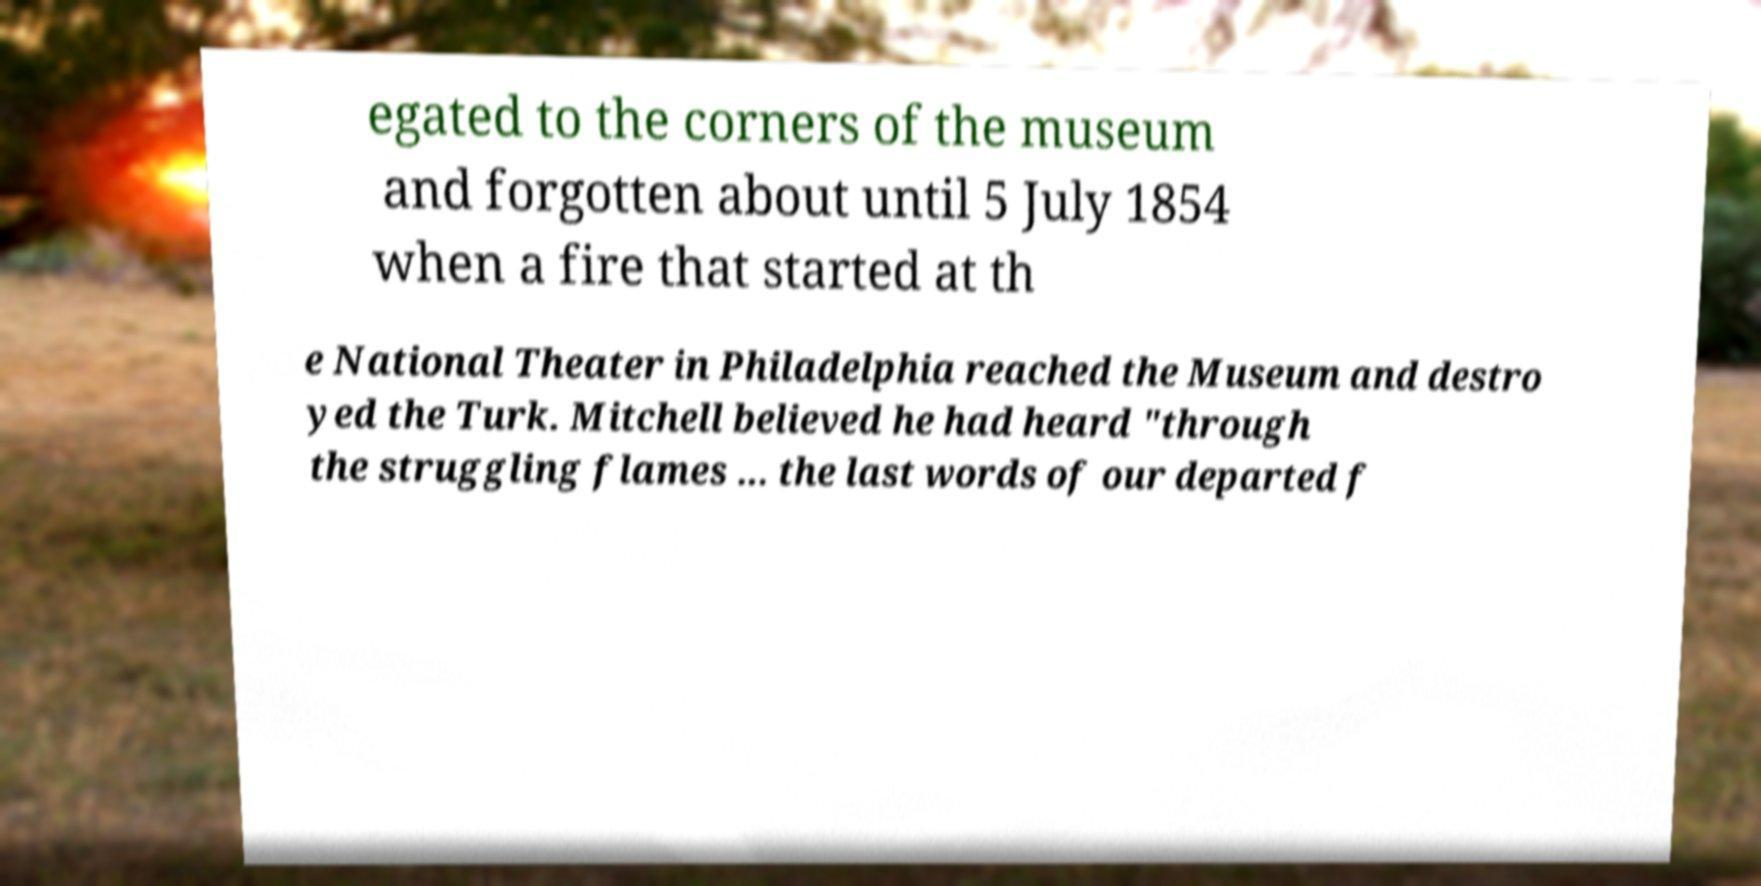Can you read and provide the text displayed in the image?This photo seems to have some interesting text. Can you extract and type it out for me? egated to the corners of the museum and forgotten about until 5 July 1854 when a fire that started at th e National Theater in Philadelphia reached the Museum and destro yed the Turk. Mitchell believed he had heard "through the struggling flames ... the last words of our departed f 